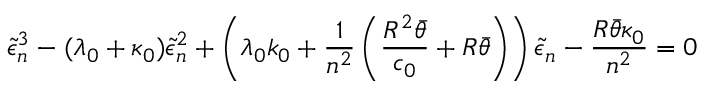Convert formula to latex. <formula><loc_0><loc_0><loc_500><loc_500>\tilde { \epsilon } _ { n } ^ { 3 } - ( \lambda _ { 0 } + \kappa _ { 0 } ) \tilde { \epsilon } _ { n } ^ { 2 } + \left ( \lambda _ { 0 } k _ { 0 } + \frac { 1 } { n ^ { 2 } } \left ( \frac { R ^ { 2 } \bar { \theta } } { c _ { 0 } } + R \bar { \theta } \right ) \right ) \tilde { \epsilon } _ { n } - \frac { R \bar { \theta } \kappa _ { 0 } } { n ^ { 2 } } = 0</formula> 